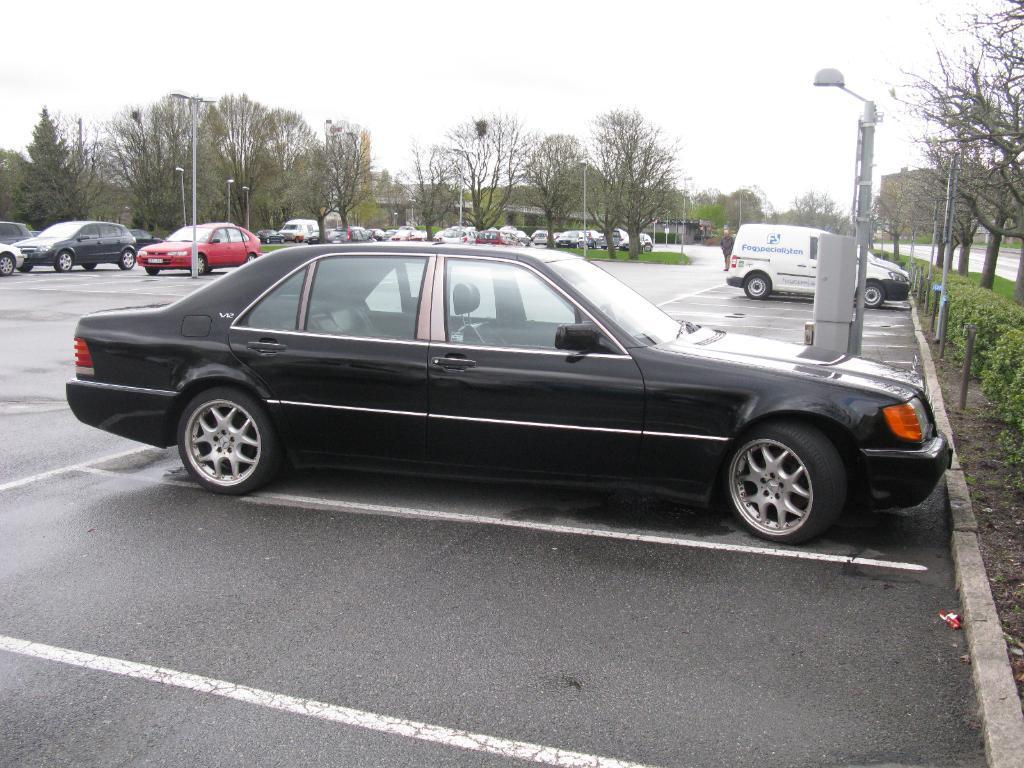In one or two sentences, can you explain what this image depicts? In this image I can see few vehicles. In front the vehicle is in black color. In the background I can see few trees, light poles and the sky is in white color. 